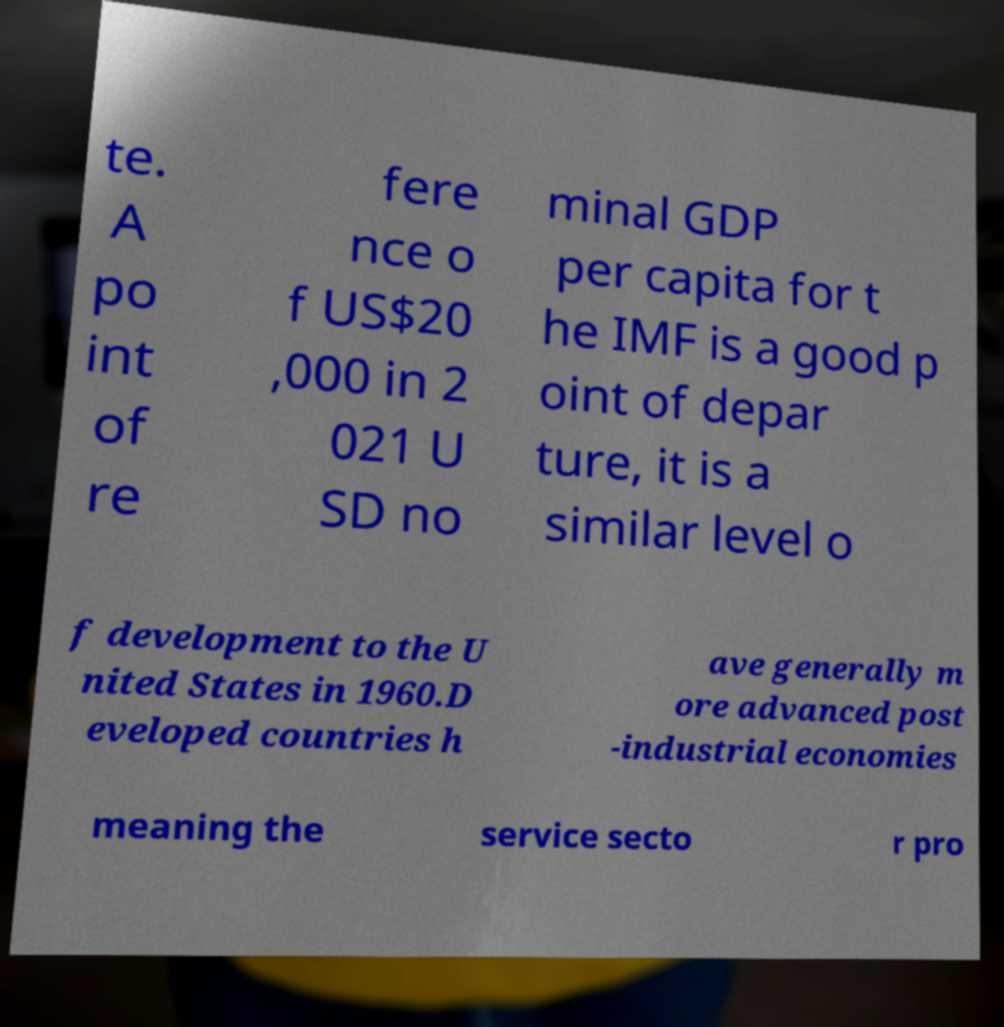I need the written content from this picture converted into text. Can you do that? te. A po int of re fere nce o f US$20 ,000 in 2 021 U SD no minal GDP per capita for t he IMF is a good p oint of depar ture, it is a similar level o f development to the U nited States in 1960.D eveloped countries h ave generally m ore advanced post -industrial economies meaning the service secto r pro 